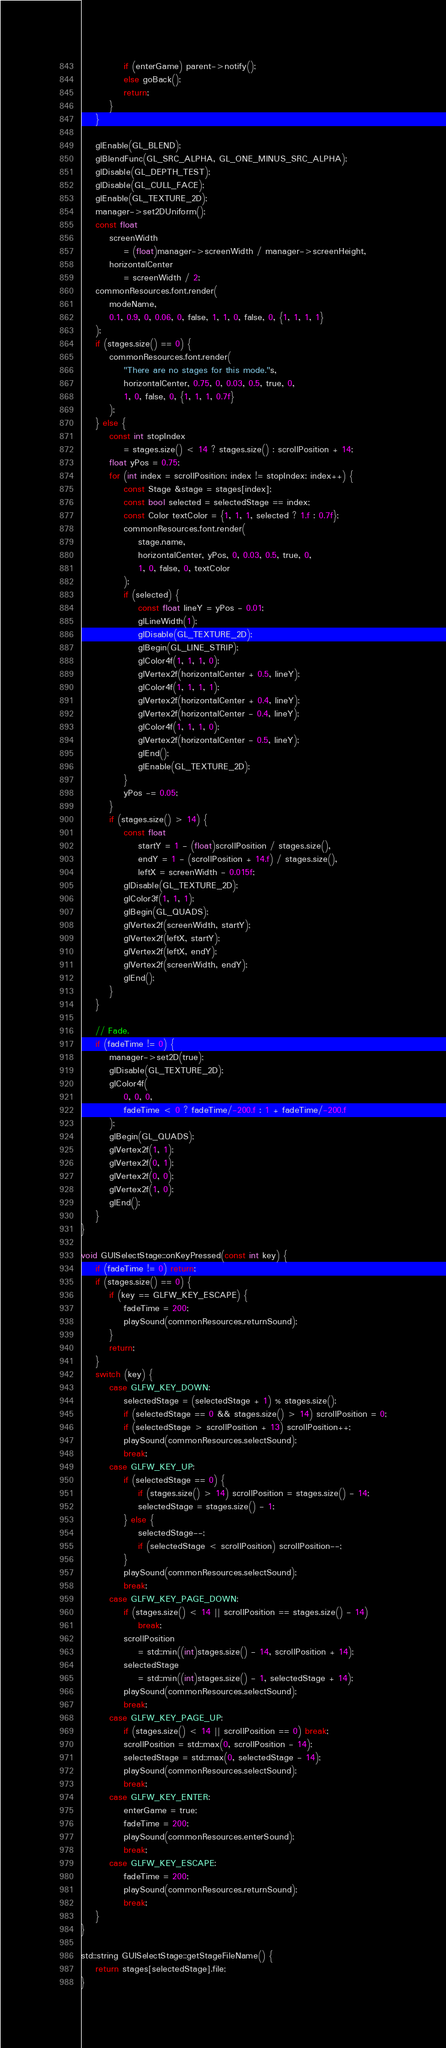<code> <loc_0><loc_0><loc_500><loc_500><_C++_>			if (enterGame) parent->notify();
			else goBack();
			return;
		}
	}

	glEnable(GL_BLEND);
	glBlendFunc(GL_SRC_ALPHA, GL_ONE_MINUS_SRC_ALPHA);
	glDisable(GL_DEPTH_TEST);
	glDisable(GL_CULL_FACE);
	glEnable(GL_TEXTURE_2D);
	manager->set2DUniform();
	const float
		screenWidth
			= (float)manager->screenWidth / manager->screenHeight,
		horizontalCenter
			= screenWidth / 2;
	commonResources.font.render(
		modeName,
		0.1, 0.9, 0, 0.06, 0, false, 1, 1, 0, false, 0, {1, 1, 1, 1}
	);
	if (stages.size() == 0) {
		commonResources.font.render(
			"There are no stages for this mode."s,
			horizontalCenter, 0.75, 0, 0.03, 0.5, true, 0,
			1, 0, false, 0, {1, 1, 1, 0.7f}
		);
	} else {
		const int stopIndex
			= stages.size() < 14 ? stages.size() : scrollPosition + 14;
		float yPos = 0.75;
		for (int index = scrollPosition; index != stopIndex; index++) {
			const Stage &stage = stages[index];
			const bool selected = selectedStage == index;
			const Color textColor = {1, 1, 1, selected ? 1.f : 0.7f};
			commonResources.font.render(
				stage.name,
				horizontalCenter, yPos, 0, 0.03, 0.5, true, 0,
				1, 0, false, 0, textColor
			);
			if (selected) {
				const float lineY = yPos - 0.01;
				glLineWidth(1);
				glDisable(GL_TEXTURE_2D);
				glBegin(GL_LINE_STRIP);
				glColor4f(1, 1, 1, 0);
				glVertex2f(horizontalCenter + 0.5, lineY);
				glColor4f(1, 1, 1, 1);
				glVertex2f(horizontalCenter + 0.4, lineY);
				glVertex2f(horizontalCenter - 0.4, lineY);
				glColor4f(1, 1, 1, 0);
				glVertex2f(horizontalCenter - 0.5, lineY);
				glEnd();
				glEnable(GL_TEXTURE_2D);
			}
			yPos -= 0.05;
		}
		if (stages.size() > 14) {
			const float
				startY = 1 - (float)scrollPosition / stages.size(),
				endY = 1 - (scrollPosition + 14.f) / stages.size(),
				leftX = screenWidth - 0.015f;
			glDisable(GL_TEXTURE_2D);
			glColor3f(1, 1, 1);
			glBegin(GL_QUADS);
			glVertex2f(screenWidth, startY);
			glVertex2f(leftX, startY);
			glVertex2f(leftX, endY);
			glVertex2f(screenWidth, endY);
			glEnd();
		}
	}

	// Fade.
	if (fadeTime != 0) {
		manager->set2D(true);
		glDisable(GL_TEXTURE_2D);
		glColor4f(
			0, 0, 0,
			fadeTime < 0 ? fadeTime/-200.f : 1 + fadeTime/-200.f
		);
		glBegin(GL_QUADS);
		glVertex2f(1, 1);
		glVertex2f(0, 1);
		glVertex2f(0, 0);
		glVertex2f(1, 0);
		glEnd();
	}
}

void GUISelectStage::onKeyPressed(const int key) {
	if (fadeTime != 0) return;
	if (stages.size() == 0) {
		if (key == GLFW_KEY_ESCAPE) {
			fadeTime = 200;
			playSound(commonResources.returnSound);
		}
		return;
	}
	switch (key) {
		case GLFW_KEY_DOWN:
			selectedStage = (selectedStage + 1) % stages.size();
			if (selectedStage == 0 && stages.size() > 14) scrollPosition = 0;
			if (selectedStage > scrollPosition + 13) scrollPosition++;
			playSound(commonResources.selectSound);
			break;
		case GLFW_KEY_UP:
			if (selectedStage == 0) {
				if (stages.size() > 14) scrollPosition = stages.size() - 14;
				selectedStage = stages.size() - 1;
			} else {
				selectedStage--;
				if (selectedStage < scrollPosition) scrollPosition--;
			}
			playSound(commonResources.selectSound);
			break;
		case GLFW_KEY_PAGE_DOWN:
			if (stages.size() < 14 || scrollPosition == stages.size() - 14)
				break;
			scrollPosition
				= std::min((int)stages.size() - 14, scrollPosition + 14);
			selectedStage
				= std::min((int)stages.size() - 1, selectedStage + 14);
			playSound(commonResources.selectSound);
			break;
		case GLFW_KEY_PAGE_UP:
			if (stages.size() < 14 || scrollPosition == 0) break;
			scrollPosition = std::max(0, scrollPosition - 14);
			selectedStage = std::max(0, selectedStage - 14);
			playSound(commonResources.selectSound);
			break;
		case GLFW_KEY_ENTER:
			enterGame = true;
			fadeTime = 200;
			playSound(commonResources.enterSound);
			break;
		case GLFW_KEY_ESCAPE:
			fadeTime = 200;
			playSound(commonResources.returnSound);
			break;
	}
}

std::string GUISelectStage::getStageFileName() {
	return stages[selectedStage].file;
}</code> 